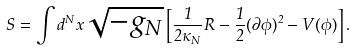Convert formula to latex. <formula><loc_0><loc_0><loc_500><loc_500>S = \int d ^ { N } x \sqrt { - g _ { N } } \left [ \frac { 1 } { 2 \kappa _ { N } } R - \frac { 1 } { 2 } ( \partial \phi ) ^ { 2 } - V ( \phi ) \right ] .</formula> 